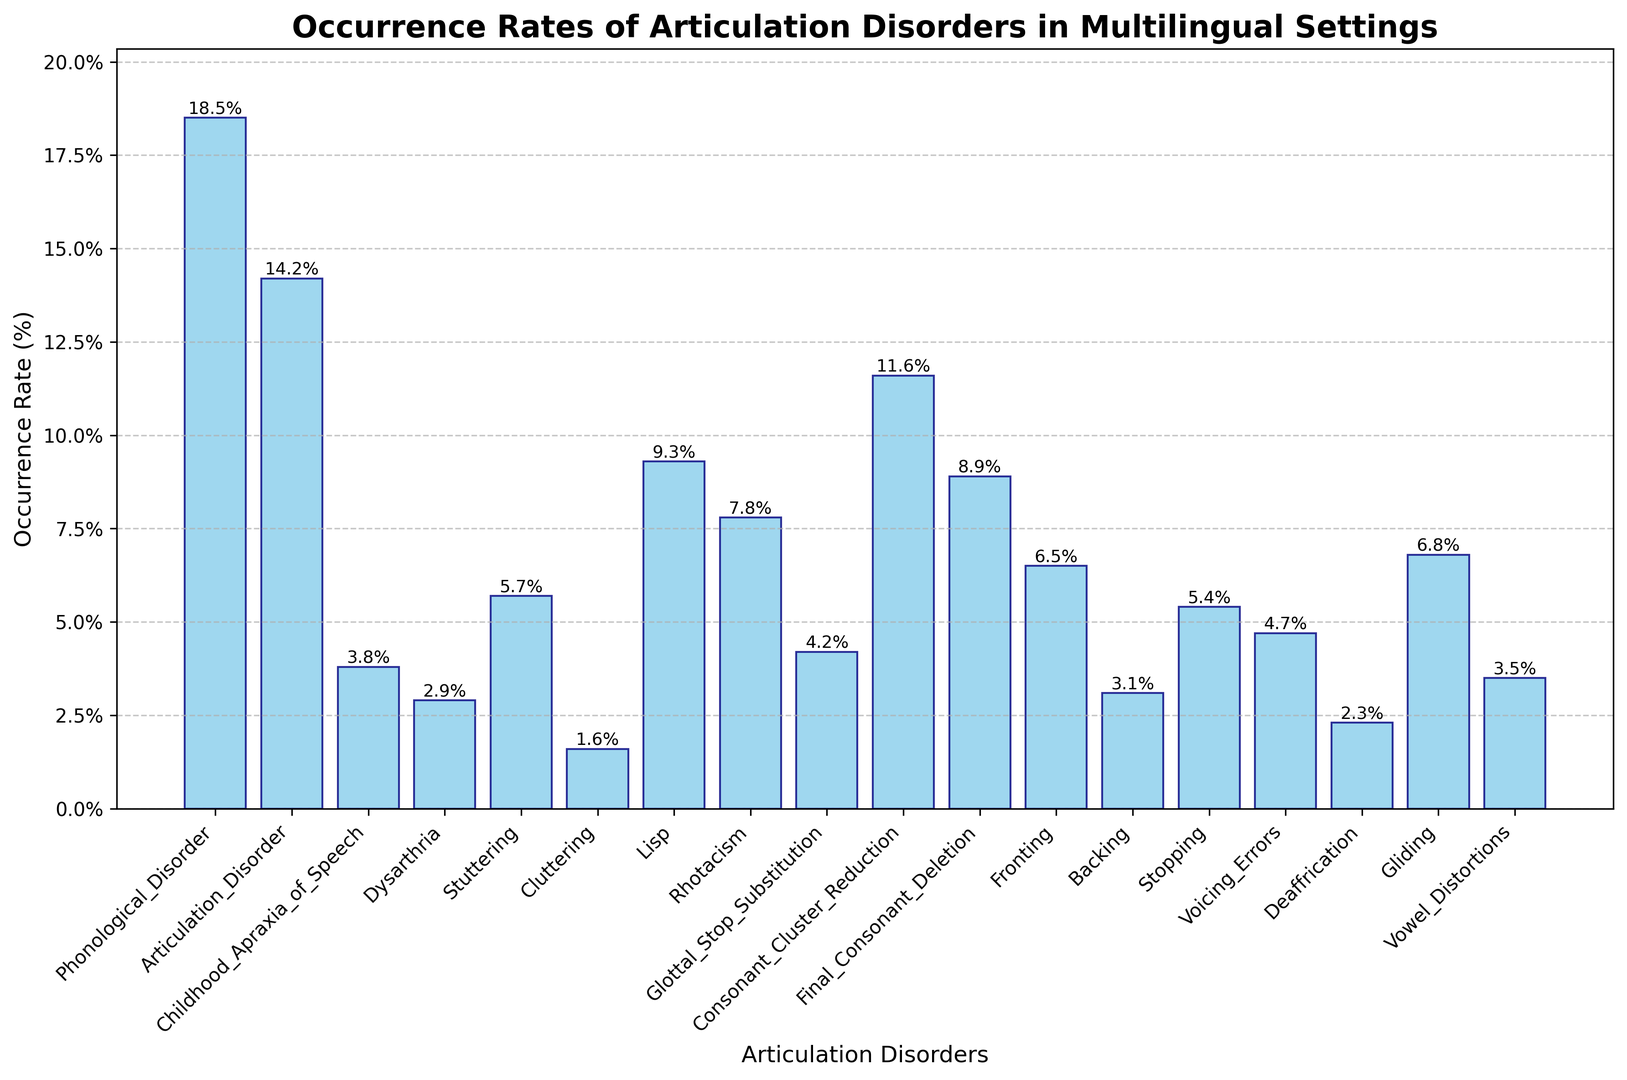What's the most frequently occurring articulation disorder in multilingual settings? Look at the bar with the highest height. The highest bar represents the disorder with the highest occurrence rate.
Answer: Phonological Disorder Which articulation disorder has a higher occurrence rate: Lisp or Stuttering? Compare the heights of the bars representing 'Lisp' and 'Stuttering'. 'Lisp' has a bar height of 9.3%, and 'Stuttering' has a bar height of 5.7%.
Answer: Lisp What is the total occurrence rate of Childhood Apraxia of Speech, Dysarthria, and Cluttering combined? Add the occurrence rates of these three disorders: 3.8% (Childhood Apraxia of Speech) + 2.9% (Dysarthria) + 1.6% (Cluttering).
Answer: 8.3% Is the occurrence rate of Rhotacism higher or lower than Voicing Errors? Compare the bar heights for 'Rhotacism' (7.8%) and 'Voicing Errors' (4.7%).
Answer: Higher Which disorder has a lower occurrence rate: Final Consonant Deletion or Gliding? Compare the heights of the bars representing 'Final Consonant Deletion' (8.9%) and 'Gliding' (6.8%).
Answer: Gliding What is the average occurrence rate of the disorders with rates greater than 5.0%? Identify bars with heights greater than 5.0%. These are Phonological Disorder (18.5%), Articulation Disorder (14.2%), Lisp (9.3%), Stuttering (5.7%), Rhotacism (7.8%), Consonant Cluster Reduction (11.6%), Final Consonant Deletion (8.9%), Fronting (6.5%), and Gliding (6.8%). Add their rates and divide by the number of disorders: (18.5% + 14.2% + 9.3% + 5.7% + 7.8% + 11.6% + 8.9% + 6.5% + 6.8%) / 9.
Answer: 9.9% Which two disorders have the closest occurrence rates? Compare the heights of the bars visually. 'Vowel Distortions' (3.5%) and 'Childhood Apraxia of Speech' (3.8%) are closest.
Answer: Vowel Distortions and Childhood Apraxia of Speech Is the combined occurrence rate of Cluttering, Rhotacism, and Deaffrication higher or lower than the occurrence rate of Phonological Disorder? Add the occurrence rates: Cluttering (1.6%) + Rhotacism (7.8%) + Deaffrication (2.3%) = 11.7%. Compare it with the occurrence rate of Phonological Disorder (18.5%).
Answer: Lower 